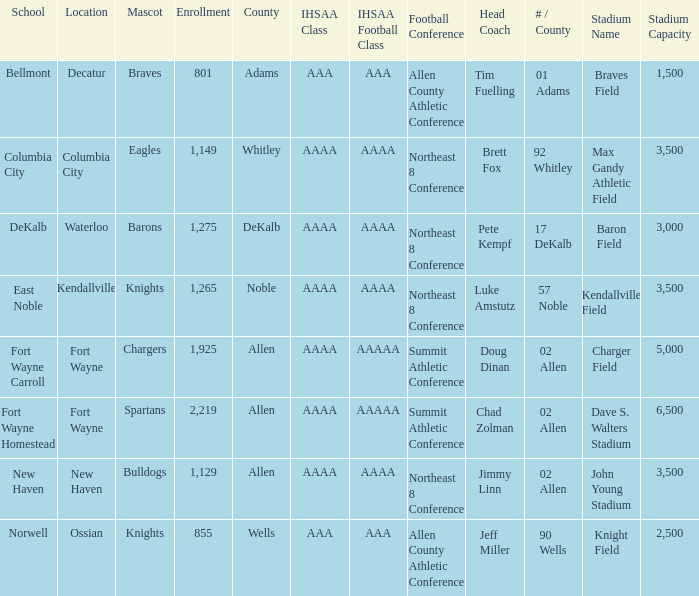What school has a mascot of the spartans with an AAAA IHSAA class and more than 1,275 enrolled? Fort Wayne Homestead. 